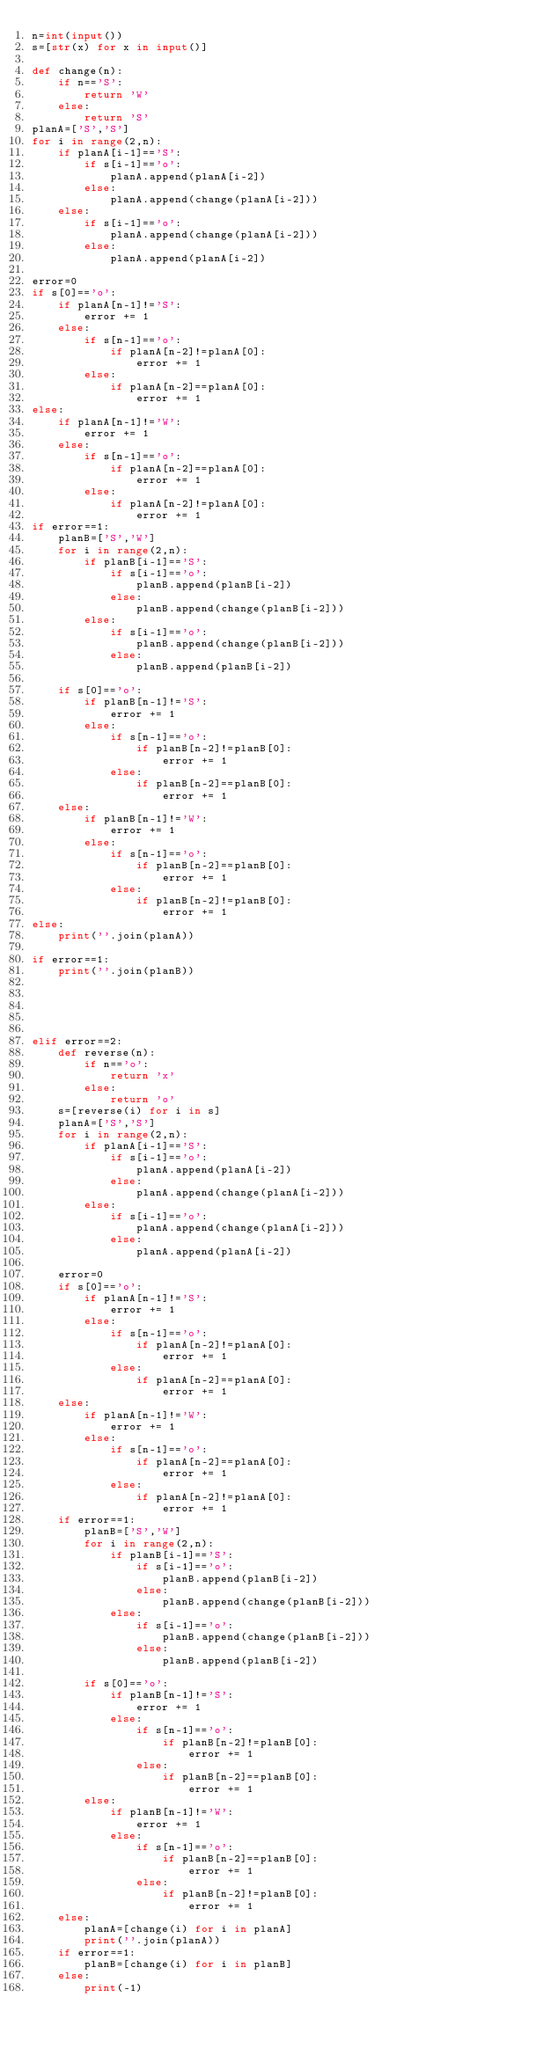Convert code to text. <code><loc_0><loc_0><loc_500><loc_500><_Python_>n=int(input())
s=[str(x) for x in input()]

def change(n):
    if n=='S':
        return 'W'
    else:
        return 'S'
planA=['S','S']
for i in range(2,n):
    if planA[i-1]=='S':
        if s[i-1]=='o':
            planA.append(planA[i-2])
        else:
            planA.append(change(planA[i-2]))
    else:
        if s[i-1]=='o':
            planA.append(change(planA[i-2]))
        else:
            planA.append(planA[i-2])

error=0
if s[0]=='o':
    if planA[n-1]!='S':
        error += 1
    else:
        if s[n-1]=='o':
            if planA[n-2]!=planA[0]:
                error += 1
        else:
            if planA[n-2]==planA[0]:
                error += 1
else:
    if planA[n-1]!='W':
        error += 1
    else:
        if s[n-1]=='o':
            if planA[n-2]==planA[0]:
                error += 1
        else:
            if planA[n-2]!=planA[0]:
                error += 1
if error==1:
    planB=['S','W']
    for i in range(2,n):
        if planB[i-1]=='S':
            if s[i-1]=='o':
                planB.append(planB[i-2])
            else:
                planB.append(change(planB[i-2]))
        else:
            if s[i-1]=='o':
                planB.append(change(planB[i-2]))
            else:
                planB.append(planB[i-2])
                
    if s[0]=='o':
        if planB[n-1]!='S':
            error += 1
        else:
            if s[n-1]=='o':
                if planB[n-2]!=planB[0]:
                    error += 1
            else:
                if planB[n-2]==planB[0]:
                    error += 1
    else:
        if planB[n-1]!='W':
            error += 1
        else:
            if s[n-1]=='o':
                if planB[n-2]==planB[0]:
                    error += 1
            else:
                if planB[n-2]!=planB[0]:
                    error += 1
else:
    print(''.join(planA))

if error==1:
    print(''.join(planB))
    
    
    
    
    
elif error==2:
    def reverse(n):
        if n=='o':
            return 'x'
        else:
            return 'o'
    s=[reverse(i) for i in s]
    planA=['S','S']
    for i in range(2,n):
        if planA[i-1]=='S':
            if s[i-1]=='o':
                planA.append(planA[i-2])
            else:
                planA.append(change(planA[i-2]))
        else:
            if s[i-1]=='o':
                planA.append(change(planA[i-2]))
            else:
                planA.append(planA[i-2])

    error=0
    if s[0]=='o':
        if planA[n-1]!='S':
            error += 1
        else:
            if s[n-1]=='o':
                if planA[n-2]!=planA[0]:
                    error += 1
            else:
                if planA[n-2]==planA[0]:
                    error += 1
    else:
        if planA[n-1]!='W':
            error += 1
        else:
            if s[n-1]=='o':
                if planA[n-2]==planA[0]:
                    error += 1
            else:
                if planA[n-2]!=planA[0]:
                    error += 1
    if error==1:
        planB=['S','W']
        for i in range(2,n):
            if planB[i-1]=='S':
                if s[i-1]=='o':
                    planB.append(planB[i-2])
                else:
                    planB.append(change(planB[i-2]))
            else:
                if s[i-1]=='o':
                    planB.append(change(planB[i-2]))
                else:
                    planB.append(planB[i-2])
                
        if s[0]=='o':
            if planB[n-1]!='S':
                error += 1
            else:
                if s[n-1]=='o':
                    if planB[n-2]!=planB[0]:
                        error += 1
                else:
                    if planB[n-2]==planB[0]:
                        error += 1
        else:
            if planB[n-1]!='W':
                error += 1
            else:
                if s[n-1]=='o':
                    if planB[n-2]==planB[0]:
                        error += 1
                else:
                    if planB[n-2]!=planB[0]:
                        error += 1
    else:
        planA=[change(i) for i in planA]
        print(''.join(planA))
    if error==1:
        planB=[change(i) for i in planB]
    else:
        print(-1)
</code> 